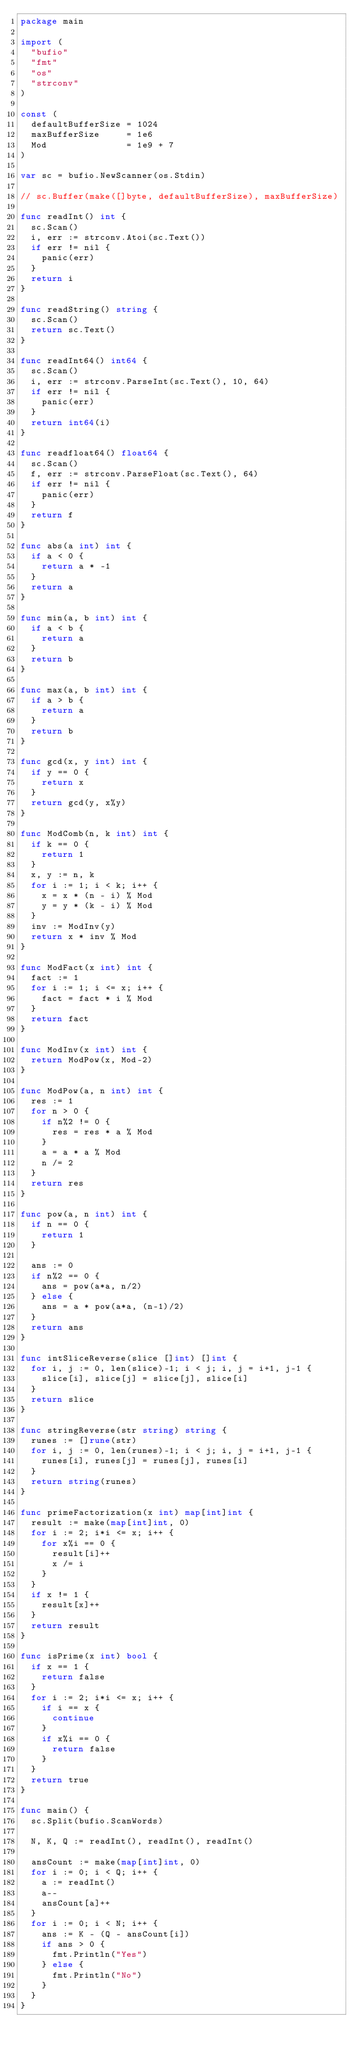<code> <loc_0><loc_0><loc_500><loc_500><_Go_>package main

import (
	"bufio"
	"fmt"
	"os"
	"strconv"
)

const (
	defaultBufferSize = 1024
	maxBufferSize     = 1e6
	Mod               = 1e9 + 7
)

var sc = bufio.NewScanner(os.Stdin)

// sc.Buffer(make([]byte, defaultBufferSize), maxBufferSize)

func readInt() int {
	sc.Scan()
	i, err := strconv.Atoi(sc.Text())
	if err != nil {
		panic(err)
	}
	return i
}

func readString() string {
	sc.Scan()
	return sc.Text()
}

func readInt64() int64 {
	sc.Scan()
	i, err := strconv.ParseInt(sc.Text(), 10, 64)
	if err != nil {
		panic(err)
	}
	return int64(i)
}

func readfloat64() float64 {
	sc.Scan()
	f, err := strconv.ParseFloat(sc.Text(), 64)
	if err != nil {
		panic(err)
	}
	return f
}

func abs(a int) int {
	if a < 0 {
		return a * -1
	}
	return a
}

func min(a, b int) int {
	if a < b {
		return a
	}
	return b
}

func max(a, b int) int {
	if a > b {
		return a
	}
	return b
}

func gcd(x, y int) int {
	if y == 0 {
		return x
	}
	return gcd(y, x%y)
}

func ModComb(n, k int) int {
	if k == 0 {
		return 1
	}
	x, y := n, k
	for i := 1; i < k; i++ {
		x = x * (n - i) % Mod
		y = y * (k - i) % Mod
	}
	inv := ModInv(y)
	return x * inv % Mod
}

func ModFact(x int) int {
	fact := 1
	for i := 1; i <= x; i++ {
		fact = fact * i % Mod
	}
	return fact
}

func ModInv(x int) int {
	return ModPow(x, Mod-2)
}

func ModPow(a, n int) int {
	res := 1
	for n > 0 {
		if n%2 != 0 {
			res = res * a % Mod
		}
		a = a * a % Mod
		n /= 2
	}
	return res
}

func pow(a, n int) int {
	if n == 0 {
		return 1
	}

	ans := 0
	if n%2 == 0 {
		ans = pow(a*a, n/2)
	} else {
		ans = a * pow(a*a, (n-1)/2)
	}
	return ans
}

func intSliceReverse(slice []int) []int {
	for i, j := 0, len(slice)-1; i < j; i, j = i+1, j-1 {
		slice[i], slice[j] = slice[j], slice[i]
	}
	return slice
}

func stringReverse(str string) string {
	runes := []rune(str)
	for i, j := 0, len(runes)-1; i < j; i, j = i+1, j-1 {
		runes[i], runes[j] = runes[j], runes[i]
	}
	return string(runes)
}

func primeFactorization(x int) map[int]int {
	result := make(map[int]int, 0)
	for i := 2; i*i <= x; i++ {
		for x%i == 0 {
			result[i]++
			x /= i
		}
	}
	if x != 1 {
		result[x]++
	}
	return result
}

func isPrime(x int) bool {
	if x == 1 {
		return false
	}
	for i := 2; i*i <= x; i++ {
		if i == x {
			continue
		}
		if x%i == 0 {
			return false
		}
	}
	return true
}

func main() {
	sc.Split(bufio.ScanWords)

	N, K, Q := readInt(), readInt(), readInt()

	ansCount := make(map[int]int, 0)
	for i := 0; i < Q; i++ {
		a := readInt()
		a--
		ansCount[a]++
	}
	for i := 0; i < N; i++ {
		ans := K - (Q - ansCount[i])
		if ans > 0 {
			fmt.Println("Yes")
		} else {
			fmt.Println("No")
		}
	}
}
</code> 